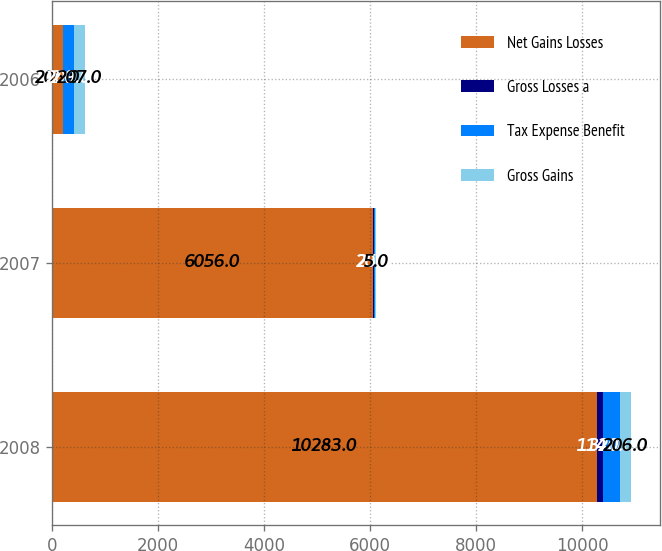Convert chart. <chart><loc_0><loc_0><loc_500><loc_500><stacked_bar_chart><ecel><fcel>2008<fcel>2007<fcel>2006<nl><fcel>Net Gains Losses<fcel>10283<fcel>6056<fcel>206<nl><fcel>Gross Losses a<fcel>114<fcel>20<fcel>2<nl><fcel>Tax Expense Benefit<fcel>320<fcel>25<fcel>209<nl><fcel>Gross Gains<fcel>206<fcel>5<fcel>207<nl></chart> 